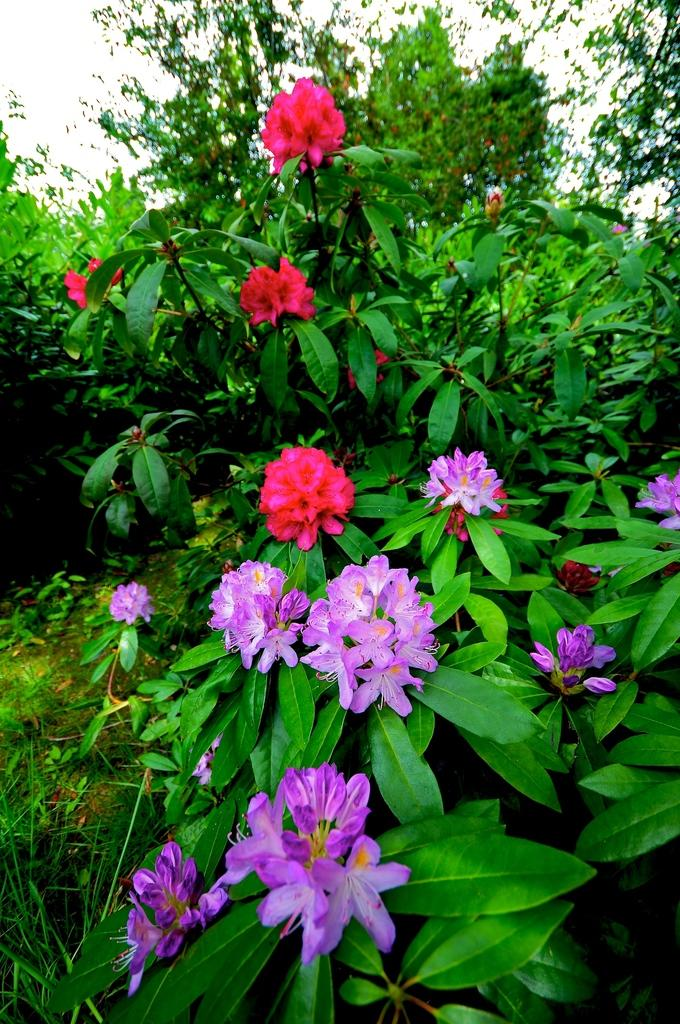What type of flowers can be seen on the plants in the image? There are plants with pink flowers and plants with violet flowers in the image. What can be seen in the background of the image? There are trees and the sky visible in the background of the image. What type of powder is being used to create the bun in the image? There is no bun or powder present in the image; it features plants with pink and violet flowers. What season is depicted in the image, considering the colors of the flowers and the fall foliage? The provided facts do not mention any season or fall foliage, so it cannot be determined from the image. 